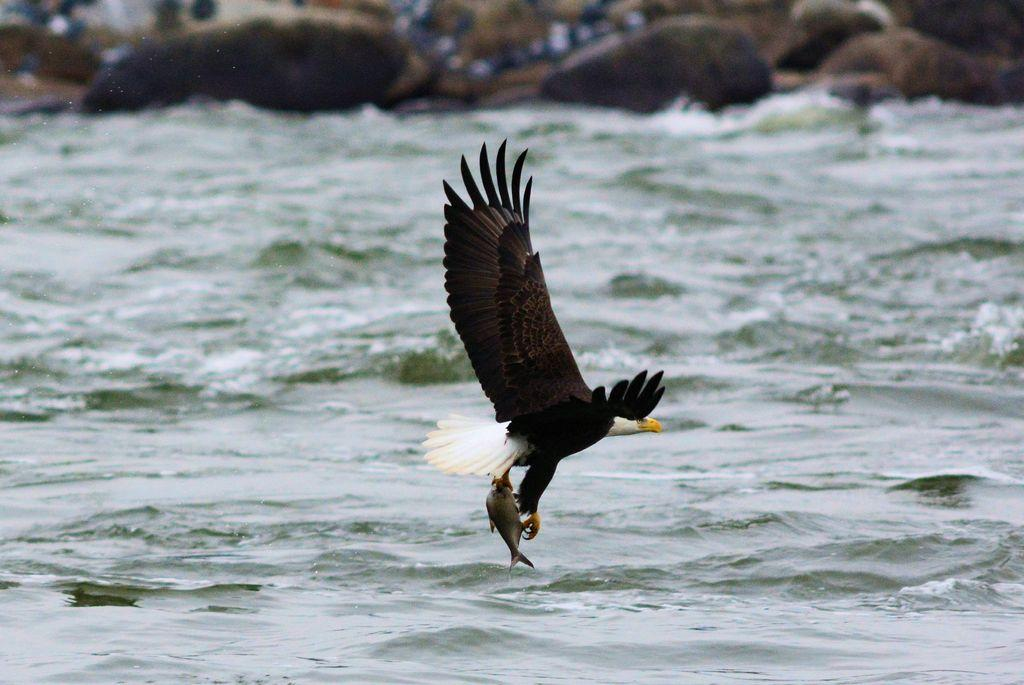What type of animal can be seen in the image? There is a black color bird in the image. What is the bird situated in? The bird is situated in water, which is visible in the image. What can be seen in the background of the image? There are rocks in the background of the image. How would you describe the quality of the background in the image? The background is slightly blurred. What type of beef is being served in the image? There is no beef present in the image; it features a black color bird in water with rocks in the background. 